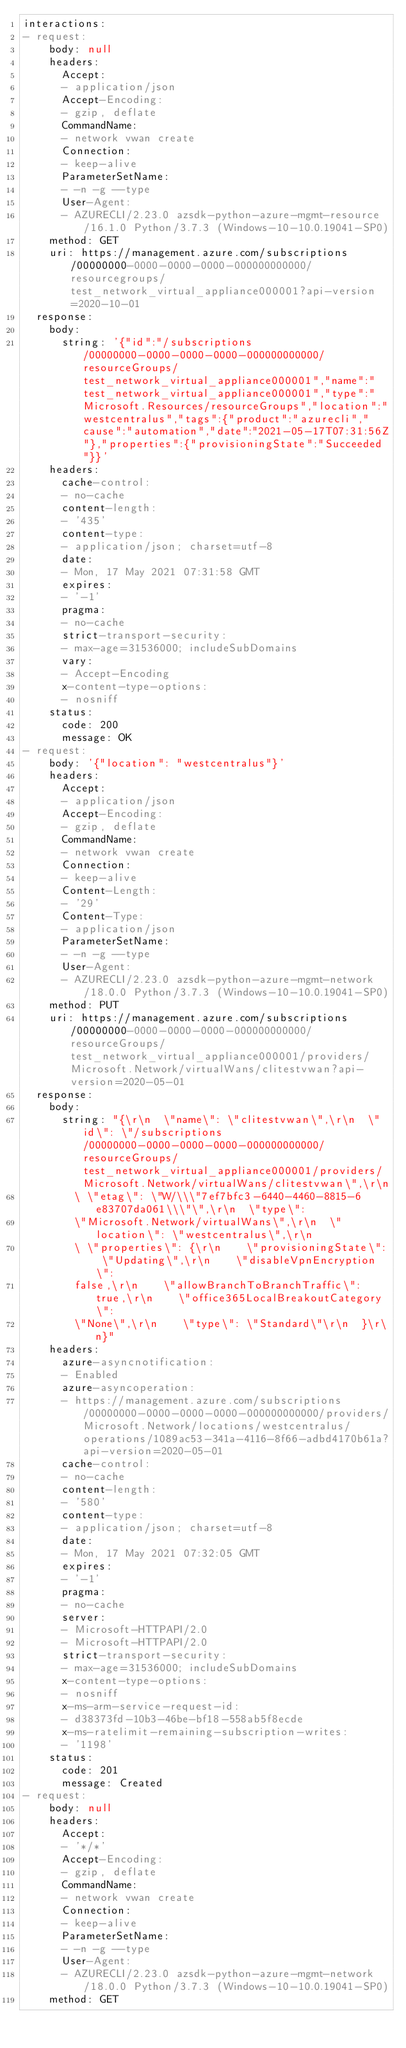<code> <loc_0><loc_0><loc_500><loc_500><_YAML_>interactions:
- request:
    body: null
    headers:
      Accept:
      - application/json
      Accept-Encoding:
      - gzip, deflate
      CommandName:
      - network vwan create
      Connection:
      - keep-alive
      ParameterSetName:
      - -n -g --type
      User-Agent:
      - AZURECLI/2.23.0 azsdk-python-azure-mgmt-resource/16.1.0 Python/3.7.3 (Windows-10-10.0.19041-SP0)
    method: GET
    uri: https://management.azure.com/subscriptions/00000000-0000-0000-0000-000000000000/resourcegroups/test_network_virtual_appliance000001?api-version=2020-10-01
  response:
    body:
      string: '{"id":"/subscriptions/00000000-0000-0000-0000-000000000000/resourceGroups/test_network_virtual_appliance000001","name":"test_network_virtual_appliance000001","type":"Microsoft.Resources/resourceGroups","location":"westcentralus","tags":{"product":"azurecli","cause":"automation","date":"2021-05-17T07:31:56Z"},"properties":{"provisioningState":"Succeeded"}}'
    headers:
      cache-control:
      - no-cache
      content-length:
      - '435'
      content-type:
      - application/json; charset=utf-8
      date:
      - Mon, 17 May 2021 07:31:58 GMT
      expires:
      - '-1'
      pragma:
      - no-cache
      strict-transport-security:
      - max-age=31536000; includeSubDomains
      vary:
      - Accept-Encoding
      x-content-type-options:
      - nosniff
    status:
      code: 200
      message: OK
- request:
    body: '{"location": "westcentralus"}'
    headers:
      Accept:
      - application/json
      Accept-Encoding:
      - gzip, deflate
      CommandName:
      - network vwan create
      Connection:
      - keep-alive
      Content-Length:
      - '29'
      Content-Type:
      - application/json
      ParameterSetName:
      - -n -g --type
      User-Agent:
      - AZURECLI/2.23.0 azsdk-python-azure-mgmt-network/18.0.0 Python/3.7.3 (Windows-10-10.0.19041-SP0)
    method: PUT
    uri: https://management.azure.com/subscriptions/00000000-0000-0000-0000-000000000000/resourceGroups/test_network_virtual_appliance000001/providers/Microsoft.Network/virtualWans/clitestvwan?api-version=2020-05-01
  response:
    body:
      string: "{\r\n  \"name\": \"clitestvwan\",\r\n  \"id\": \"/subscriptions/00000000-0000-0000-0000-000000000000/resourceGroups/test_network_virtual_appliance000001/providers/Microsoft.Network/virtualWans/clitestvwan\",\r\n
        \ \"etag\": \"W/\\\"7ef7bfc3-6440-4460-8815-6e83707da061\\\"\",\r\n  \"type\":
        \"Microsoft.Network/virtualWans\",\r\n  \"location\": \"westcentralus\",\r\n
        \ \"properties\": {\r\n    \"provisioningState\": \"Updating\",\r\n    \"disableVpnEncryption\":
        false,\r\n    \"allowBranchToBranchTraffic\": true,\r\n    \"office365LocalBreakoutCategory\":
        \"None\",\r\n    \"type\": \"Standard\"\r\n  }\r\n}"
    headers:
      azure-asyncnotification:
      - Enabled
      azure-asyncoperation:
      - https://management.azure.com/subscriptions/00000000-0000-0000-0000-000000000000/providers/Microsoft.Network/locations/westcentralus/operations/1089ac53-341a-4116-8f66-adbd4170b61a?api-version=2020-05-01
      cache-control:
      - no-cache
      content-length:
      - '580'
      content-type:
      - application/json; charset=utf-8
      date:
      - Mon, 17 May 2021 07:32:05 GMT
      expires:
      - '-1'
      pragma:
      - no-cache
      server:
      - Microsoft-HTTPAPI/2.0
      - Microsoft-HTTPAPI/2.0
      strict-transport-security:
      - max-age=31536000; includeSubDomains
      x-content-type-options:
      - nosniff
      x-ms-arm-service-request-id:
      - d38373fd-10b3-46be-bf18-558ab5f8ecde
      x-ms-ratelimit-remaining-subscription-writes:
      - '1198'
    status:
      code: 201
      message: Created
- request:
    body: null
    headers:
      Accept:
      - '*/*'
      Accept-Encoding:
      - gzip, deflate
      CommandName:
      - network vwan create
      Connection:
      - keep-alive
      ParameterSetName:
      - -n -g --type
      User-Agent:
      - AZURECLI/2.23.0 azsdk-python-azure-mgmt-network/18.0.0 Python/3.7.3 (Windows-10-10.0.19041-SP0)
    method: GET</code> 